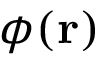<formula> <loc_0><loc_0><loc_500><loc_500>\phi ( r )</formula> 